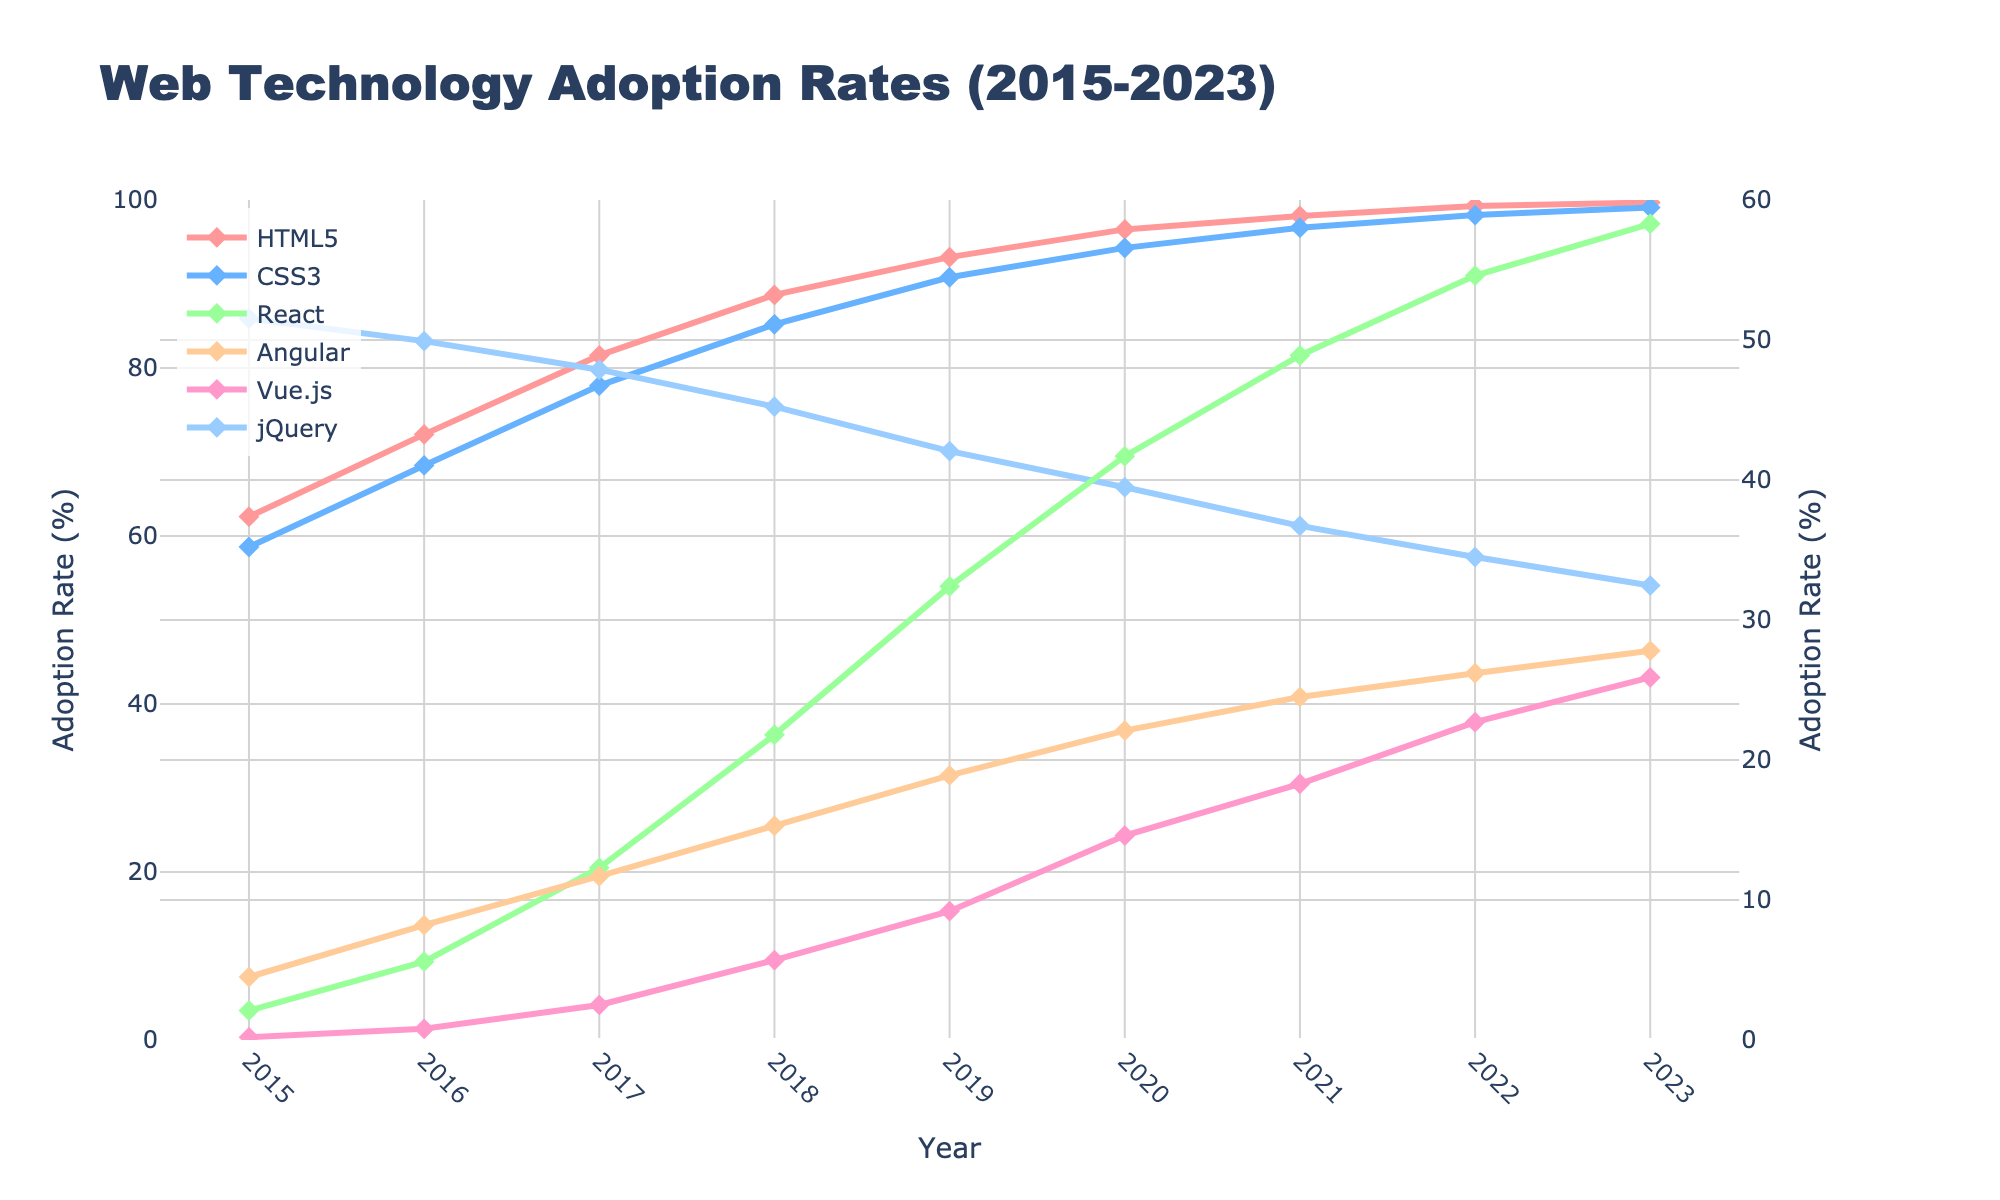Which web technology had the highest adoption rate in 2015? Look at the data points for the year 2015. Compare the adoption rates of HTML5, CSS3, React, Angular, Vue.js, and jQuery. HTML5 has the highest adoption rate.
Answer: HTML5 How did the adoption rate of jQuery change from 2015 to 2023? Check the adoption rates of jQuery for the years 2015 and 2023. Subtract the rate in 2023 from the rate in 2015 to find the change. The adoption rate decreased from 85.9% in 2015 to 54.1% in 2023.
Answer: Decreased Which year did React surpass Angular in adoption rate? Identify the years where the lines for React and Angular intersect or when React's line goes above Angular's. This occurs in 2019, where React has a higher adoption rate.
Answer: 2019 What was the average adoption rate of HTML5 from 2015 to 2023? Add up the adoption rates of HTML5 for each year from 2015 to 2023 and divide by the number of years (9). The sum is 791.3%, and the average is 791.3 / 9 = 87.92%.
Answer: 87.92% Compare the adoption rate trends of Vue.js and Angular over time. Observe the lines for Vue.js and Angular. Vue.js starts much lower than Angular but rises continuously, whereas Angular shows slower growth after 2020.
Answer: Vue.js rising faster Which web technology showed the most consistent increase in adoption rate from 2015 to 2023? Look at the trend lines for all technologies and determine which one has the most steadily increasing line without significant drops or fluctuations. HTML5 consistently increases every year.
Answer: HTML5 Between 2021 and 2023, which technology saw the greatest increase in adoption rate? Calculate the difference in adoption rates between 2021 and 2023 for each technology. React increased from 48.9% in 2021 to 58.3% in 2023, which is a 9.4% increase, the highest among all.
Answer: React How did the adoption rate of CSS3 in 2020 compare to HTML5 in 2016? Compare the adoption rate of CSS3 in 2020 to HTML5 in 2016. CSS3 had a rate of 94.3%, while HTML5 had 72.1%. CSS3 in 2020 is higher.
Answer: CSS3 higher What is the difference in the adoption rate of React between 2017 and 2023? Subtract React's adoption rate in 2017 from its rate in 2023. The difference is 58.3% - 12.3% = 46.0%.
Answer: 46.0% Between 2018 and 2020, which technology had the largest drop in adoption rate? Calculate the difference in adoption rates for each technology between 2018 and 2020. jQuery dropped from 75.4% in 2018 to 65.8% in 2020, a decrease of 9.6%, which is the largest drop.
Answer: jQuery 